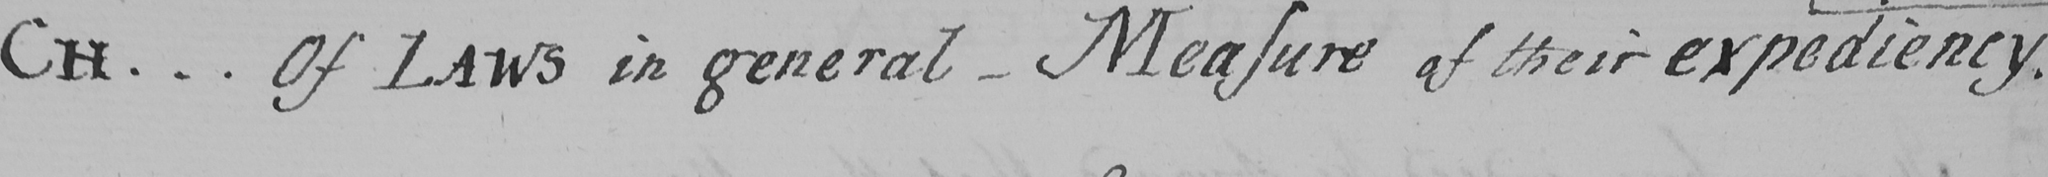What text is written in this handwritten line? CH .. . Of LAWS in general  _  Measure of their expediency . 